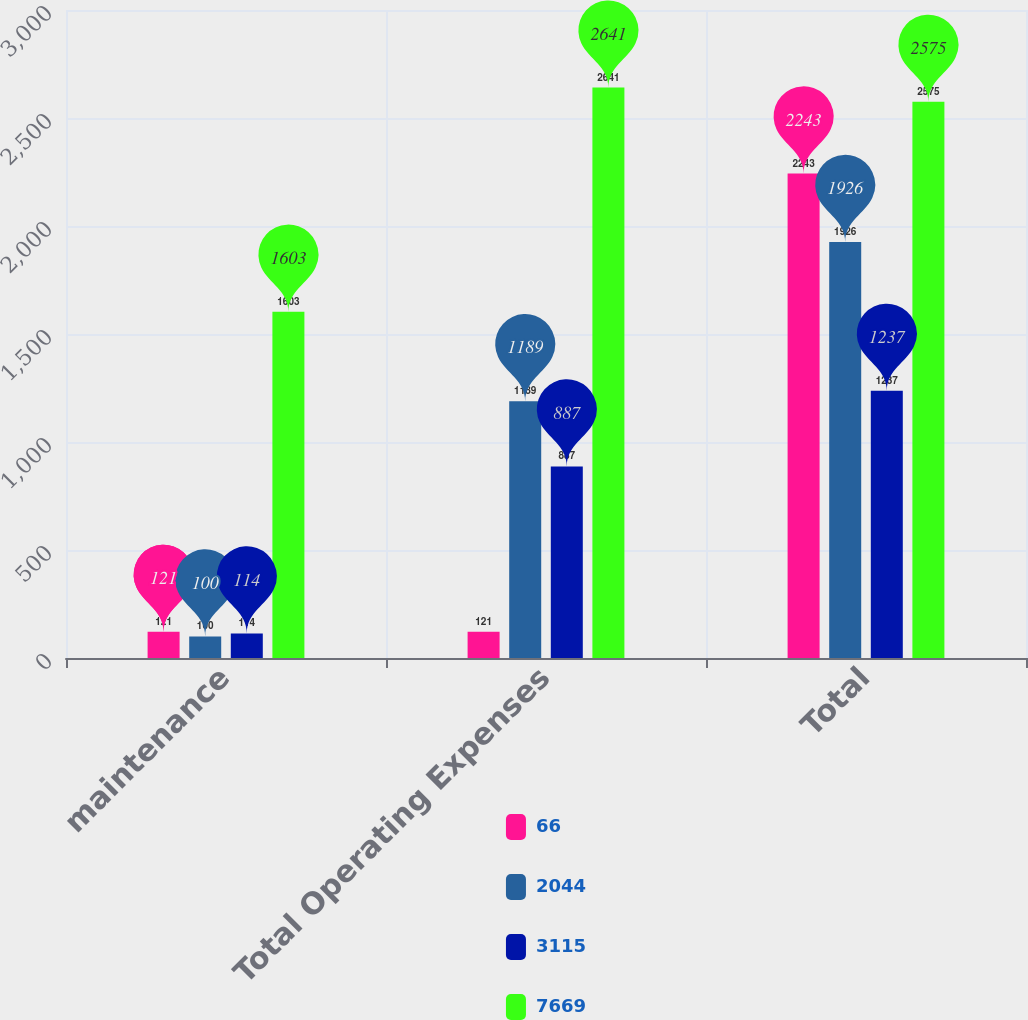Convert chart. <chart><loc_0><loc_0><loc_500><loc_500><stacked_bar_chart><ecel><fcel>maintenance<fcel>Total Operating Expenses<fcel>Total<nl><fcel>66<fcel>121<fcel>121<fcel>2243<nl><fcel>2044<fcel>100<fcel>1189<fcel>1926<nl><fcel>3115<fcel>114<fcel>887<fcel>1237<nl><fcel>7669<fcel>1603<fcel>2641<fcel>2575<nl></chart> 